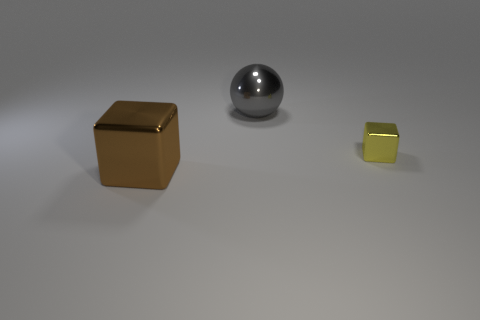There is a large shiny thing that is in front of the large object to the right of the big thing to the left of the large gray thing; what shape is it?
Ensure brevity in your answer.  Cube. There is a yellow thing; is it the same size as the shiny object in front of the yellow metal thing?
Your answer should be compact. No. The metallic object that is both to the left of the yellow block and in front of the gray ball is what color?
Give a very brief answer. Brown. How many other objects are the same shape as the yellow metallic thing?
Your answer should be very brief. 1. There is a block that is behind the big brown shiny thing; does it have the same color as the block that is left of the big gray metal object?
Provide a short and direct response. No. Do the thing behind the small cube and the shiny cube in front of the tiny yellow block have the same size?
Your answer should be compact. Yes. Is there any other thing that is made of the same material as the big gray ball?
Provide a short and direct response. Yes. What is the material of the big thing that is in front of the big metal thing right of the shiny object on the left side of the gray ball?
Offer a terse response. Metal. Does the gray metal thing have the same shape as the large brown metal thing?
Offer a terse response. No. There is a large brown object that is the same shape as the tiny metallic object; what is its material?
Provide a short and direct response. Metal. 